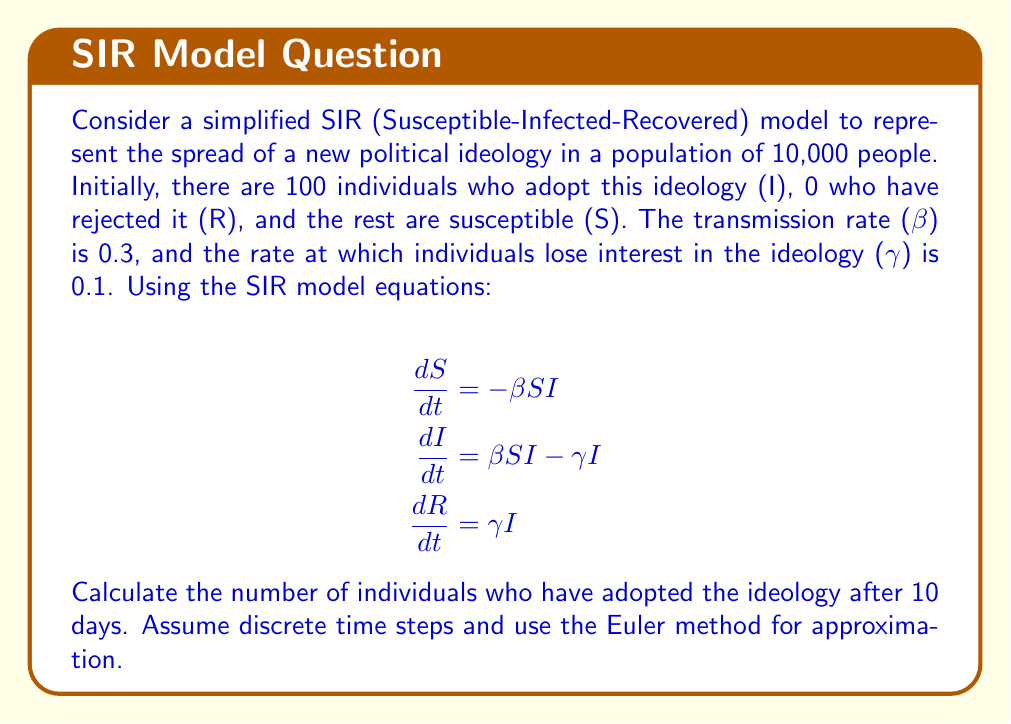Help me with this question. To solve this problem, we'll use the Euler method to approximate the SIR model over 10 days. We'll calculate the values for S, I, and R at each day, focusing on the value of I after 10 days.

Initial conditions:
S(0) = 9900
I(0) = 100
R(0) = 0
β = 0.3
γ = 0.1
Δt = 1 day

Euler method equations:
$$S(t+1) = S(t) + (-\beta S(t)I(t)) \Delta t$$
$$I(t+1) = I(t) + (\beta S(t)I(t) - \gamma I(t)) \Delta t$$
$$R(t+1) = R(t) + (\gamma I(t)) \Delta t$$

Let's calculate for each day:

Day 0:
S(0) = 9900, I(0) = 100, R(0) = 0

Day 1:
S(1) = 9900 + (-0.3 * 9900 * 100) * 1 = 9603
I(1) = 100 + (0.3 * 9900 * 100 - 0.1 * 100) * 1 = 387
R(1) = 0 + (0.1 * 100) * 1 = 10

Day 2:
S(2) = 9603 + (-0.3 * 9603 * 387) * 1 = 8491.97
I(2) = 387 + (0.3 * 9603 * 387 - 0.1 * 387) * 1 = 1478.39
R(2) = 10 + (0.1 * 387) * 1 = 48.7

Continuing this process for the remaining days:

Day 3: I(3) = 3244.76
Day 4: I(4) = 4843.72
Day 5: I(5) = 5388.59
Day 6: I(6) = 4963.48
Day 7: I(7) = 4112.24
Day 8: I(8) = 3196.98
Day 9: I(9) = 2399.74
Day 10: I(10) = 1763.81

After 10 days, approximately 1764 individuals have adopted the ideology.
Answer: 1764 individuals 